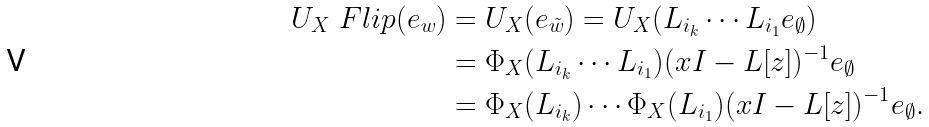<formula> <loc_0><loc_0><loc_500><loc_500>U _ { X } \ F l i p ( e _ { w } ) & = U _ { X } ( e _ { \tilde { w } } ) = U _ { X } ( L _ { i _ { k } } \cdots L _ { i _ { 1 } } { e _ { \emptyset } } ) \\ & = \Phi _ { X } ( L _ { i _ { k } } \cdots L _ { i _ { 1 } } ) ( x I - L [ { z } ] ) ^ { - 1 } { e _ { \emptyset } } \\ & = \Phi _ { X } ( L _ { i _ { k } } ) \cdots \Phi _ { X } ( L _ { i _ { 1 } } ) ( x I - L [ { z } ] ) ^ { - 1 } { e _ { \emptyset } } .</formula> 